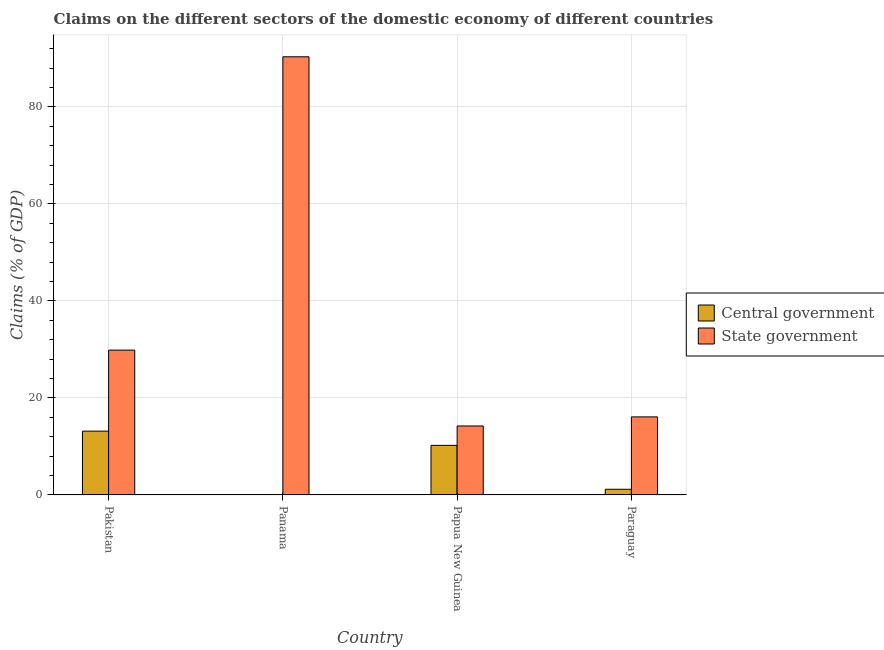Are the number of bars on each tick of the X-axis equal?
Provide a short and direct response. No. How many bars are there on the 3rd tick from the left?
Offer a terse response. 2. How many bars are there on the 3rd tick from the right?
Keep it short and to the point. 1. What is the label of the 1st group of bars from the left?
Provide a succinct answer. Pakistan. What is the claims on state government in Paraguay?
Ensure brevity in your answer.  16.1. Across all countries, what is the maximum claims on state government?
Provide a short and direct response. 90.35. Across all countries, what is the minimum claims on state government?
Your answer should be very brief. 14.22. What is the total claims on central government in the graph?
Offer a very short reply. 24.55. What is the difference between the claims on state government in Pakistan and that in Paraguay?
Your answer should be compact. 13.77. What is the difference between the claims on state government in Papua New Guinea and the claims on central government in Pakistan?
Your answer should be very brief. 1.06. What is the average claims on state government per country?
Provide a succinct answer. 37.63. What is the difference between the claims on central government and claims on state government in Pakistan?
Give a very brief answer. -16.71. What is the ratio of the claims on state government in Panama to that in Papua New Guinea?
Offer a terse response. 6.35. Is the difference between the claims on state government in Pakistan and Paraguay greater than the difference between the claims on central government in Pakistan and Paraguay?
Provide a succinct answer. Yes. What is the difference between the highest and the second highest claims on state government?
Provide a succinct answer. 60.49. What is the difference between the highest and the lowest claims on state government?
Ensure brevity in your answer.  76.13. In how many countries, is the claims on central government greater than the average claims on central government taken over all countries?
Your response must be concise. 2. Is the sum of the claims on state government in Papua New Guinea and Paraguay greater than the maximum claims on central government across all countries?
Give a very brief answer. Yes. How many bars are there?
Offer a terse response. 7. How many countries are there in the graph?
Make the answer very short. 4. How many legend labels are there?
Offer a terse response. 2. What is the title of the graph?
Ensure brevity in your answer.  Claims on the different sectors of the domestic economy of different countries. Does "Secondary school" appear as one of the legend labels in the graph?
Your answer should be compact. No. What is the label or title of the Y-axis?
Your answer should be compact. Claims (% of GDP). What is the Claims (% of GDP) in Central government in Pakistan?
Your answer should be very brief. 13.16. What is the Claims (% of GDP) of State government in Pakistan?
Provide a short and direct response. 29.86. What is the Claims (% of GDP) of Central government in Panama?
Offer a terse response. 0. What is the Claims (% of GDP) of State government in Panama?
Give a very brief answer. 90.35. What is the Claims (% of GDP) in Central government in Papua New Guinea?
Ensure brevity in your answer.  10.22. What is the Claims (% of GDP) of State government in Papua New Guinea?
Your answer should be very brief. 14.22. What is the Claims (% of GDP) in Central government in Paraguay?
Your response must be concise. 1.17. What is the Claims (% of GDP) in State government in Paraguay?
Your answer should be very brief. 16.1. Across all countries, what is the maximum Claims (% of GDP) of Central government?
Offer a very short reply. 13.16. Across all countries, what is the maximum Claims (% of GDP) of State government?
Give a very brief answer. 90.35. Across all countries, what is the minimum Claims (% of GDP) of Central government?
Provide a succinct answer. 0. Across all countries, what is the minimum Claims (% of GDP) in State government?
Ensure brevity in your answer.  14.22. What is the total Claims (% of GDP) in Central government in the graph?
Keep it short and to the point. 24.55. What is the total Claims (% of GDP) in State government in the graph?
Make the answer very short. 150.53. What is the difference between the Claims (% of GDP) in State government in Pakistan and that in Panama?
Your response must be concise. -60.49. What is the difference between the Claims (% of GDP) in Central government in Pakistan and that in Papua New Guinea?
Ensure brevity in your answer.  2.93. What is the difference between the Claims (% of GDP) in State government in Pakistan and that in Papua New Guinea?
Offer a very short reply. 15.64. What is the difference between the Claims (% of GDP) in Central government in Pakistan and that in Paraguay?
Your answer should be compact. 11.99. What is the difference between the Claims (% of GDP) of State government in Pakistan and that in Paraguay?
Give a very brief answer. 13.77. What is the difference between the Claims (% of GDP) in State government in Panama and that in Papua New Guinea?
Offer a very short reply. 76.13. What is the difference between the Claims (% of GDP) in State government in Panama and that in Paraguay?
Your response must be concise. 74.26. What is the difference between the Claims (% of GDP) in Central government in Papua New Guinea and that in Paraguay?
Provide a short and direct response. 9.06. What is the difference between the Claims (% of GDP) in State government in Papua New Guinea and that in Paraguay?
Your answer should be compact. -1.88. What is the difference between the Claims (% of GDP) in Central government in Pakistan and the Claims (% of GDP) in State government in Panama?
Your answer should be very brief. -77.2. What is the difference between the Claims (% of GDP) in Central government in Pakistan and the Claims (% of GDP) in State government in Papua New Guinea?
Make the answer very short. -1.06. What is the difference between the Claims (% of GDP) in Central government in Pakistan and the Claims (% of GDP) in State government in Paraguay?
Your response must be concise. -2.94. What is the difference between the Claims (% of GDP) in Central government in Papua New Guinea and the Claims (% of GDP) in State government in Paraguay?
Provide a short and direct response. -5.87. What is the average Claims (% of GDP) of Central government per country?
Give a very brief answer. 6.14. What is the average Claims (% of GDP) in State government per country?
Keep it short and to the point. 37.63. What is the difference between the Claims (% of GDP) of Central government and Claims (% of GDP) of State government in Pakistan?
Your answer should be very brief. -16.71. What is the difference between the Claims (% of GDP) in Central government and Claims (% of GDP) in State government in Papua New Guinea?
Offer a terse response. -3.99. What is the difference between the Claims (% of GDP) in Central government and Claims (% of GDP) in State government in Paraguay?
Ensure brevity in your answer.  -14.93. What is the ratio of the Claims (% of GDP) of State government in Pakistan to that in Panama?
Provide a succinct answer. 0.33. What is the ratio of the Claims (% of GDP) in Central government in Pakistan to that in Papua New Guinea?
Keep it short and to the point. 1.29. What is the ratio of the Claims (% of GDP) in State government in Pakistan to that in Papua New Guinea?
Offer a very short reply. 2.1. What is the ratio of the Claims (% of GDP) of Central government in Pakistan to that in Paraguay?
Provide a short and direct response. 11.28. What is the ratio of the Claims (% of GDP) in State government in Pakistan to that in Paraguay?
Give a very brief answer. 1.86. What is the ratio of the Claims (% of GDP) of State government in Panama to that in Papua New Guinea?
Ensure brevity in your answer.  6.35. What is the ratio of the Claims (% of GDP) of State government in Panama to that in Paraguay?
Keep it short and to the point. 5.61. What is the ratio of the Claims (% of GDP) in Central government in Papua New Guinea to that in Paraguay?
Your answer should be compact. 8.77. What is the ratio of the Claims (% of GDP) in State government in Papua New Guinea to that in Paraguay?
Offer a terse response. 0.88. What is the difference between the highest and the second highest Claims (% of GDP) in Central government?
Your answer should be compact. 2.93. What is the difference between the highest and the second highest Claims (% of GDP) in State government?
Keep it short and to the point. 60.49. What is the difference between the highest and the lowest Claims (% of GDP) of Central government?
Keep it short and to the point. 13.16. What is the difference between the highest and the lowest Claims (% of GDP) of State government?
Provide a succinct answer. 76.13. 